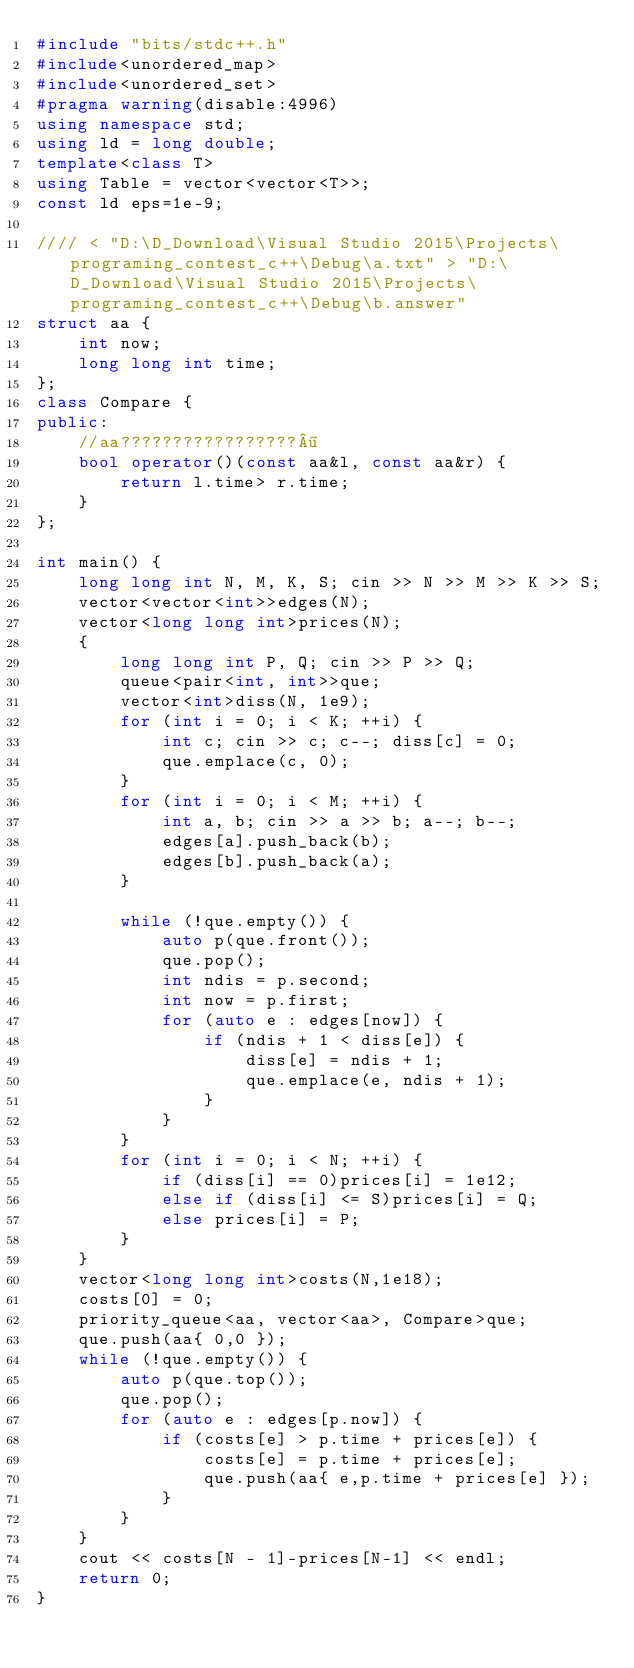Convert code to text. <code><loc_0><loc_0><loc_500><loc_500><_C++_>#include "bits/stdc++.h"
#include<unordered_map>
#include<unordered_set>
#pragma warning(disable:4996)
using namespace std;
using ld = long double;
template<class T>
using Table = vector<vector<T>>;
const ld eps=1e-9;

//// < "D:\D_Download\Visual Studio 2015\Projects\programing_contest_c++\Debug\a.txt" > "D:\D_Download\Visual Studio 2015\Projects\programing_contest_c++\Debug\b.answer"
struct aa {
	int now;
	long long int time;
};
class Compare {
public:
	//aa?????????????????¶
	bool operator()(const aa&l, const aa&r) {
		return l.time> r.time;
	}
};

int main() {
	long long int N, M, K, S; cin >> N >> M >> K >> S;
	vector<vector<int>>edges(N);
	vector<long long int>prices(N);
	{
		long long int P, Q; cin >> P >> Q;
		queue<pair<int, int>>que;
		vector<int>diss(N, 1e9);
		for (int i = 0; i < K; ++i) {
			int c; cin >> c; c--; diss[c] = 0;
			que.emplace(c, 0);
		}
		for (int i = 0; i < M; ++i) {
			int a, b; cin >> a >> b; a--; b--;
			edges[a].push_back(b);
			edges[b].push_back(a);
		}

		while (!que.empty()) {
			auto p(que.front());
			que.pop();
			int ndis = p.second;
			int now = p.first;
			for (auto e : edges[now]) {
				if (ndis + 1 < diss[e]) {
					diss[e] = ndis + 1;
					que.emplace(e, ndis + 1);
				}
			}
		}
		for (int i = 0; i < N; ++i) {
			if (diss[i] == 0)prices[i] = 1e12;
			else if (diss[i] <= S)prices[i] = Q;
			else prices[i] = P;
		}
	}
	vector<long long int>costs(N,1e18);
	costs[0] = 0;
	priority_queue<aa, vector<aa>, Compare>que;
	que.push(aa{ 0,0 });
	while (!que.empty()) {
		auto p(que.top());
		que.pop();
		for (auto e : edges[p.now]) {
			if (costs[e] > p.time + prices[e]) {
				costs[e] = p.time + prices[e];
				que.push(aa{ e,p.time + prices[e] });
			}
		}
	}
	cout << costs[N - 1]-prices[N-1] << endl;
	return 0;
}</code> 